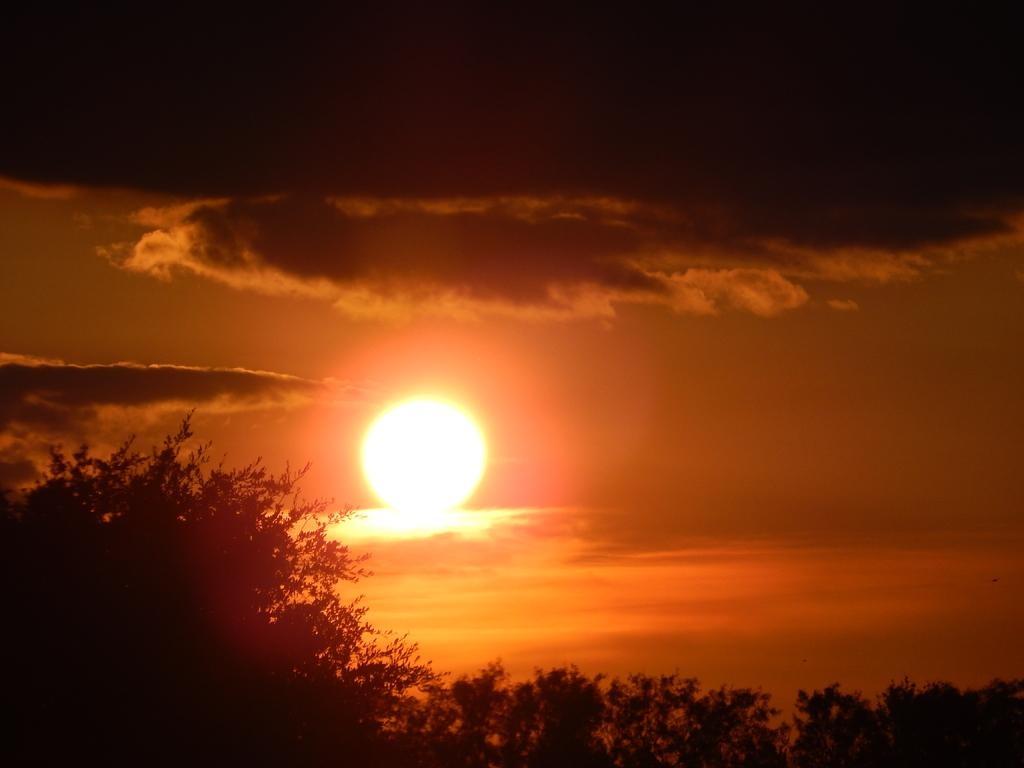What type of vegetation can be seen in the image? There are trees in the image. What is visible at the top of the image? The sky is visible at the top of the image. What celestial body can be seen in the sky? The sun is present in the sky. What else can be seen in the sky besides the sun? Clouds are visible in the sky. Where is the library located in the image? There is no library present in the image. Is there a volcano erupting in the image? There is no volcano present in the image. 